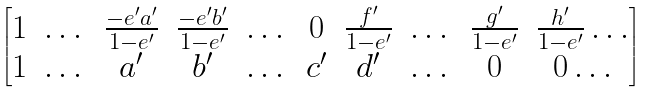<formula> <loc_0><loc_0><loc_500><loc_500>\begin{bmatrix} 1 & \dots & \frac { - e ^ { \prime } a ^ { \prime } } { 1 - e ^ { \prime } } & \frac { - e ^ { \prime } b ^ { \prime } } { 1 - e ^ { \prime } } & \dots & 0 & \frac { f ^ { \prime } } { 1 - e ^ { \prime } } & \dots & \frac { g ^ { \prime } } { 1 - e ^ { \prime } } & \frac { h ^ { \prime } } { 1 - e ^ { \prime } } \dots \\ 1 & \dots & a ^ { \prime } & b ^ { \prime } & \dots & c ^ { \prime } & d ^ { \prime } & \dots & 0 & 0 \dots \end{bmatrix}</formula> 